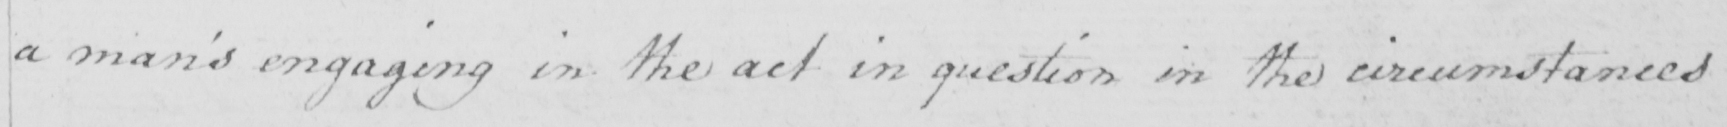Please transcribe the handwritten text in this image. a man ' s engaging in the act in question in the circumstances 